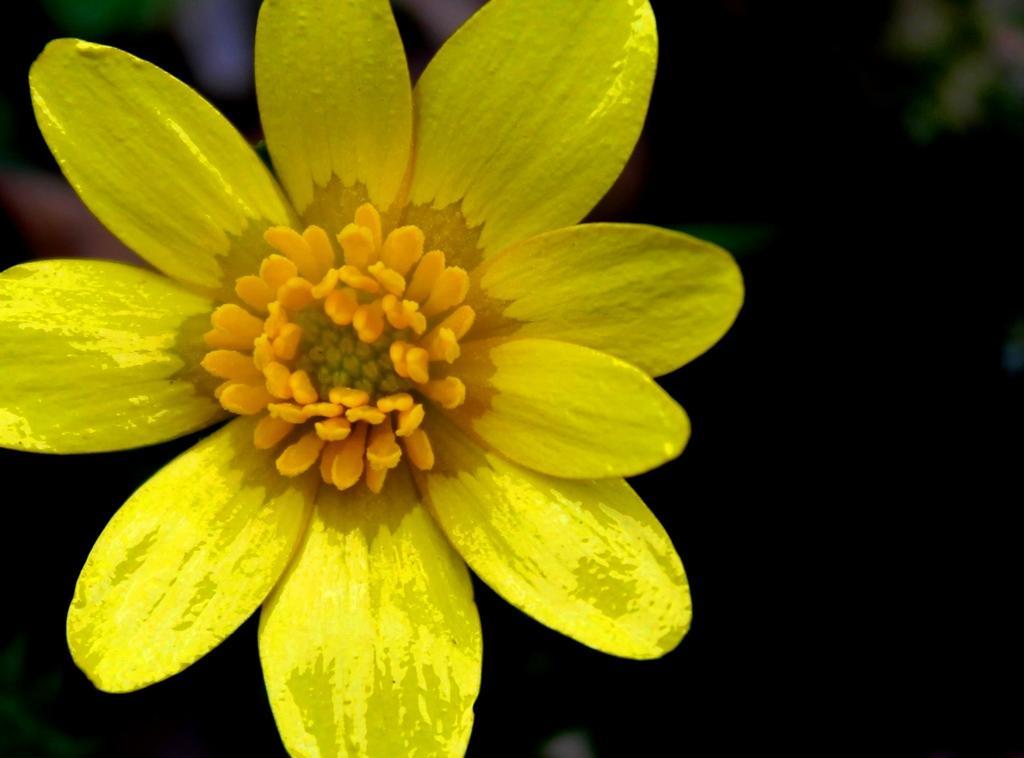Can you describe this image briefly? It is a flower in yellow color. 